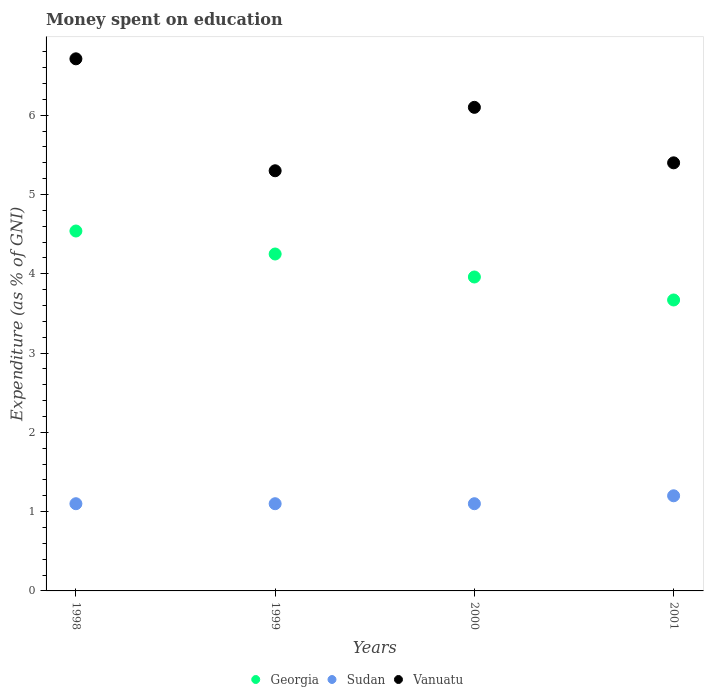How many different coloured dotlines are there?
Your response must be concise. 3. Is the number of dotlines equal to the number of legend labels?
Make the answer very short. Yes. What is the amount of money spent on education in Georgia in 1999?
Keep it short and to the point. 4.25. Across all years, what is the maximum amount of money spent on education in Georgia?
Your answer should be very brief. 4.54. In which year was the amount of money spent on education in Sudan maximum?
Your answer should be very brief. 2001. In which year was the amount of money spent on education in Sudan minimum?
Keep it short and to the point. 1998. What is the total amount of money spent on education in Georgia in the graph?
Offer a terse response. 16.42. What is the difference between the amount of money spent on education in Sudan in 2000 and that in 2001?
Make the answer very short. -0.1. What is the difference between the amount of money spent on education in Vanuatu in 1999 and the amount of money spent on education in Sudan in 2001?
Your response must be concise. 4.1. What is the average amount of money spent on education in Georgia per year?
Provide a short and direct response. 4.11. In the year 2001, what is the difference between the amount of money spent on education in Vanuatu and amount of money spent on education in Sudan?
Your answer should be very brief. 4.2. In how many years, is the amount of money spent on education in Georgia greater than 5.4 %?
Your response must be concise. 0. What is the ratio of the amount of money spent on education in Vanuatu in 1998 to that in 1999?
Ensure brevity in your answer.  1.27. Is the difference between the amount of money spent on education in Vanuatu in 1999 and 2001 greater than the difference between the amount of money spent on education in Sudan in 1999 and 2001?
Provide a succinct answer. No. What is the difference between the highest and the second highest amount of money spent on education in Vanuatu?
Provide a succinct answer. 0.61. What is the difference between the highest and the lowest amount of money spent on education in Georgia?
Your response must be concise. 0.87. In how many years, is the amount of money spent on education in Georgia greater than the average amount of money spent on education in Georgia taken over all years?
Your response must be concise. 2. Is the sum of the amount of money spent on education in Sudan in 1998 and 2000 greater than the maximum amount of money spent on education in Georgia across all years?
Provide a short and direct response. No. Is it the case that in every year, the sum of the amount of money spent on education in Sudan and amount of money spent on education in Georgia  is greater than the amount of money spent on education in Vanuatu?
Offer a terse response. No. Does the amount of money spent on education in Georgia monotonically increase over the years?
Make the answer very short. No. Are the values on the major ticks of Y-axis written in scientific E-notation?
Your answer should be very brief. No. Does the graph contain any zero values?
Your answer should be very brief. No. What is the title of the graph?
Provide a short and direct response. Money spent on education. What is the label or title of the Y-axis?
Offer a very short reply. Expenditure (as % of GNI). What is the Expenditure (as % of GNI) in Georgia in 1998?
Keep it short and to the point. 4.54. What is the Expenditure (as % of GNI) in Sudan in 1998?
Your answer should be very brief. 1.1. What is the Expenditure (as % of GNI) in Vanuatu in 1998?
Your answer should be compact. 6.71. What is the Expenditure (as % of GNI) of Georgia in 1999?
Provide a short and direct response. 4.25. What is the Expenditure (as % of GNI) of Vanuatu in 1999?
Give a very brief answer. 5.3. What is the Expenditure (as % of GNI) in Georgia in 2000?
Offer a terse response. 3.96. What is the Expenditure (as % of GNI) of Sudan in 2000?
Ensure brevity in your answer.  1.1. What is the Expenditure (as % of GNI) in Vanuatu in 2000?
Your answer should be compact. 6.1. What is the Expenditure (as % of GNI) in Georgia in 2001?
Offer a very short reply. 3.67. What is the Expenditure (as % of GNI) of Sudan in 2001?
Keep it short and to the point. 1.2. Across all years, what is the maximum Expenditure (as % of GNI) of Georgia?
Make the answer very short. 4.54. Across all years, what is the maximum Expenditure (as % of GNI) of Sudan?
Provide a short and direct response. 1.2. Across all years, what is the maximum Expenditure (as % of GNI) in Vanuatu?
Give a very brief answer. 6.71. Across all years, what is the minimum Expenditure (as % of GNI) in Georgia?
Offer a very short reply. 3.67. Across all years, what is the minimum Expenditure (as % of GNI) in Sudan?
Offer a very short reply. 1.1. What is the total Expenditure (as % of GNI) of Georgia in the graph?
Give a very brief answer. 16.42. What is the total Expenditure (as % of GNI) of Sudan in the graph?
Keep it short and to the point. 4.5. What is the total Expenditure (as % of GNI) in Vanuatu in the graph?
Keep it short and to the point. 23.51. What is the difference between the Expenditure (as % of GNI) of Georgia in 1998 and that in 1999?
Keep it short and to the point. 0.29. What is the difference between the Expenditure (as % of GNI) in Vanuatu in 1998 and that in 1999?
Provide a succinct answer. 1.41. What is the difference between the Expenditure (as % of GNI) of Georgia in 1998 and that in 2000?
Make the answer very short. 0.58. What is the difference between the Expenditure (as % of GNI) of Vanuatu in 1998 and that in 2000?
Provide a short and direct response. 0.61. What is the difference between the Expenditure (as % of GNI) in Georgia in 1998 and that in 2001?
Ensure brevity in your answer.  0.87. What is the difference between the Expenditure (as % of GNI) of Sudan in 1998 and that in 2001?
Your answer should be compact. -0.1. What is the difference between the Expenditure (as % of GNI) of Vanuatu in 1998 and that in 2001?
Offer a terse response. 1.31. What is the difference between the Expenditure (as % of GNI) in Georgia in 1999 and that in 2000?
Give a very brief answer. 0.29. What is the difference between the Expenditure (as % of GNI) in Georgia in 1999 and that in 2001?
Your answer should be very brief. 0.58. What is the difference between the Expenditure (as % of GNI) of Georgia in 2000 and that in 2001?
Your answer should be very brief. 0.29. What is the difference between the Expenditure (as % of GNI) in Vanuatu in 2000 and that in 2001?
Provide a short and direct response. 0.7. What is the difference between the Expenditure (as % of GNI) of Georgia in 1998 and the Expenditure (as % of GNI) of Sudan in 1999?
Provide a short and direct response. 3.44. What is the difference between the Expenditure (as % of GNI) in Georgia in 1998 and the Expenditure (as % of GNI) in Vanuatu in 1999?
Your response must be concise. -0.76. What is the difference between the Expenditure (as % of GNI) in Sudan in 1998 and the Expenditure (as % of GNI) in Vanuatu in 1999?
Provide a short and direct response. -4.2. What is the difference between the Expenditure (as % of GNI) in Georgia in 1998 and the Expenditure (as % of GNI) in Sudan in 2000?
Offer a very short reply. 3.44. What is the difference between the Expenditure (as % of GNI) of Georgia in 1998 and the Expenditure (as % of GNI) of Vanuatu in 2000?
Provide a short and direct response. -1.56. What is the difference between the Expenditure (as % of GNI) of Sudan in 1998 and the Expenditure (as % of GNI) of Vanuatu in 2000?
Your response must be concise. -5. What is the difference between the Expenditure (as % of GNI) of Georgia in 1998 and the Expenditure (as % of GNI) of Sudan in 2001?
Ensure brevity in your answer.  3.34. What is the difference between the Expenditure (as % of GNI) in Georgia in 1998 and the Expenditure (as % of GNI) in Vanuatu in 2001?
Ensure brevity in your answer.  -0.86. What is the difference between the Expenditure (as % of GNI) in Georgia in 1999 and the Expenditure (as % of GNI) in Sudan in 2000?
Make the answer very short. 3.15. What is the difference between the Expenditure (as % of GNI) in Georgia in 1999 and the Expenditure (as % of GNI) in Vanuatu in 2000?
Give a very brief answer. -1.85. What is the difference between the Expenditure (as % of GNI) in Sudan in 1999 and the Expenditure (as % of GNI) in Vanuatu in 2000?
Ensure brevity in your answer.  -5. What is the difference between the Expenditure (as % of GNI) in Georgia in 1999 and the Expenditure (as % of GNI) in Sudan in 2001?
Provide a succinct answer. 3.05. What is the difference between the Expenditure (as % of GNI) in Georgia in 1999 and the Expenditure (as % of GNI) in Vanuatu in 2001?
Ensure brevity in your answer.  -1.15. What is the difference between the Expenditure (as % of GNI) in Georgia in 2000 and the Expenditure (as % of GNI) in Sudan in 2001?
Provide a short and direct response. 2.76. What is the difference between the Expenditure (as % of GNI) of Georgia in 2000 and the Expenditure (as % of GNI) of Vanuatu in 2001?
Your answer should be very brief. -1.44. What is the average Expenditure (as % of GNI) in Georgia per year?
Your response must be concise. 4.11. What is the average Expenditure (as % of GNI) of Sudan per year?
Offer a terse response. 1.12. What is the average Expenditure (as % of GNI) of Vanuatu per year?
Provide a succinct answer. 5.88. In the year 1998, what is the difference between the Expenditure (as % of GNI) in Georgia and Expenditure (as % of GNI) in Sudan?
Offer a very short reply. 3.44. In the year 1998, what is the difference between the Expenditure (as % of GNI) in Georgia and Expenditure (as % of GNI) in Vanuatu?
Keep it short and to the point. -2.17. In the year 1998, what is the difference between the Expenditure (as % of GNI) in Sudan and Expenditure (as % of GNI) in Vanuatu?
Give a very brief answer. -5.61. In the year 1999, what is the difference between the Expenditure (as % of GNI) in Georgia and Expenditure (as % of GNI) in Sudan?
Offer a very short reply. 3.15. In the year 1999, what is the difference between the Expenditure (as % of GNI) of Georgia and Expenditure (as % of GNI) of Vanuatu?
Make the answer very short. -1.05. In the year 2000, what is the difference between the Expenditure (as % of GNI) in Georgia and Expenditure (as % of GNI) in Sudan?
Provide a short and direct response. 2.86. In the year 2000, what is the difference between the Expenditure (as % of GNI) of Georgia and Expenditure (as % of GNI) of Vanuatu?
Provide a succinct answer. -2.14. In the year 2001, what is the difference between the Expenditure (as % of GNI) of Georgia and Expenditure (as % of GNI) of Sudan?
Make the answer very short. 2.47. In the year 2001, what is the difference between the Expenditure (as % of GNI) of Georgia and Expenditure (as % of GNI) of Vanuatu?
Give a very brief answer. -1.73. In the year 2001, what is the difference between the Expenditure (as % of GNI) in Sudan and Expenditure (as % of GNI) in Vanuatu?
Give a very brief answer. -4.2. What is the ratio of the Expenditure (as % of GNI) in Georgia in 1998 to that in 1999?
Offer a terse response. 1.07. What is the ratio of the Expenditure (as % of GNI) in Vanuatu in 1998 to that in 1999?
Give a very brief answer. 1.27. What is the ratio of the Expenditure (as % of GNI) of Georgia in 1998 to that in 2000?
Your answer should be compact. 1.15. What is the ratio of the Expenditure (as % of GNI) in Sudan in 1998 to that in 2000?
Provide a succinct answer. 1. What is the ratio of the Expenditure (as % of GNI) of Vanuatu in 1998 to that in 2000?
Ensure brevity in your answer.  1.1. What is the ratio of the Expenditure (as % of GNI) in Georgia in 1998 to that in 2001?
Your answer should be compact. 1.24. What is the ratio of the Expenditure (as % of GNI) of Vanuatu in 1998 to that in 2001?
Your answer should be very brief. 1.24. What is the ratio of the Expenditure (as % of GNI) of Georgia in 1999 to that in 2000?
Keep it short and to the point. 1.07. What is the ratio of the Expenditure (as % of GNI) in Vanuatu in 1999 to that in 2000?
Offer a very short reply. 0.87. What is the ratio of the Expenditure (as % of GNI) of Georgia in 1999 to that in 2001?
Offer a terse response. 1.16. What is the ratio of the Expenditure (as % of GNI) in Vanuatu in 1999 to that in 2001?
Provide a succinct answer. 0.98. What is the ratio of the Expenditure (as % of GNI) of Georgia in 2000 to that in 2001?
Provide a short and direct response. 1.08. What is the ratio of the Expenditure (as % of GNI) of Sudan in 2000 to that in 2001?
Your answer should be very brief. 0.92. What is the ratio of the Expenditure (as % of GNI) of Vanuatu in 2000 to that in 2001?
Keep it short and to the point. 1.13. What is the difference between the highest and the second highest Expenditure (as % of GNI) in Georgia?
Offer a very short reply. 0.29. What is the difference between the highest and the second highest Expenditure (as % of GNI) in Vanuatu?
Offer a terse response. 0.61. What is the difference between the highest and the lowest Expenditure (as % of GNI) of Georgia?
Ensure brevity in your answer.  0.87. What is the difference between the highest and the lowest Expenditure (as % of GNI) of Vanuatu?
Give a very brief answer. 1.41. 